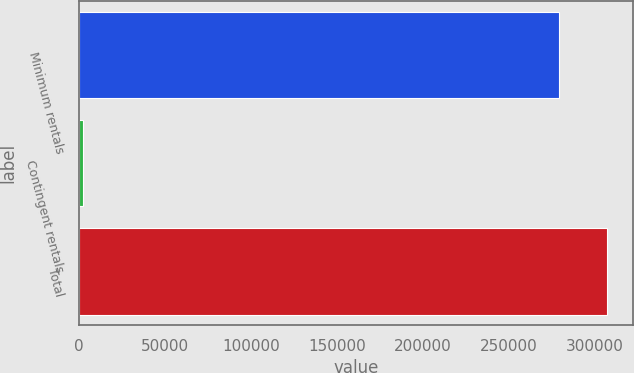Convert chart. <chart><loc_0><loc_0><loc_500><loc_500><bar_chart><fcel>Minimum rentals<fcel>Contingent rentals<fcel>Total<nl><fcel>278812<fcel>2317<fcel>306693<nl></chart> 